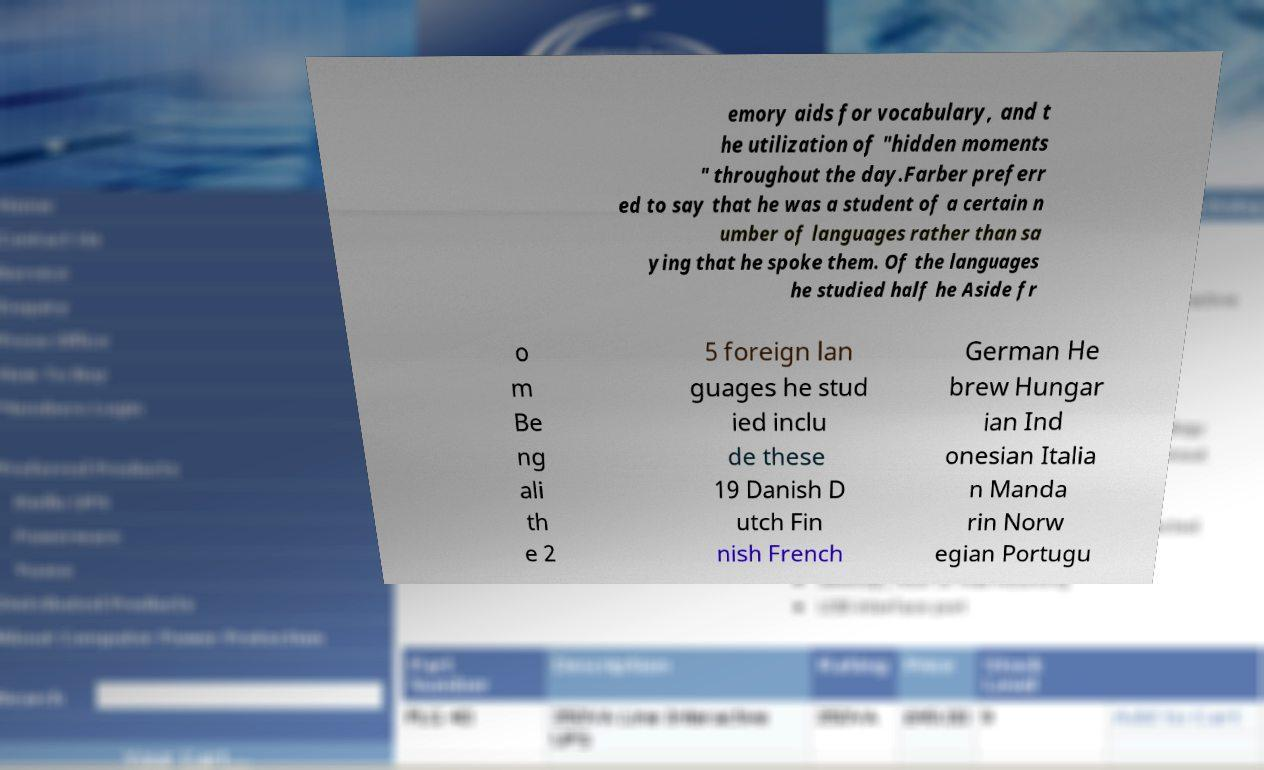Could you assist in decoding the text presented in this image and type it out clearly? emory aids for vocabulary, and t he utilization of "hidden moments " throughout the day.Farber preferr ed to say that he was a student of a certain n umber of languages rather than sa ying that he spoke them. Of the languages he studied half he Aside fr o m Be ng ali th e 2 5 foreign lan guages he stud ied inclu de these 19 Danish D utch Fin nish French German He brew Hungar ian Ind onesian Italia n Manda rin Norw egian Portugu 